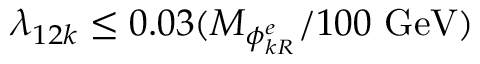Convert formula to latex. <formula><loc_0><loc_0><loc_500><loc_500>\lambda _ { 1 2 k } \leq 0 . 0 3 ( M _ { \phi _ { k R } ^ { e } } / 1 0 0 \ G e V )</formula> 